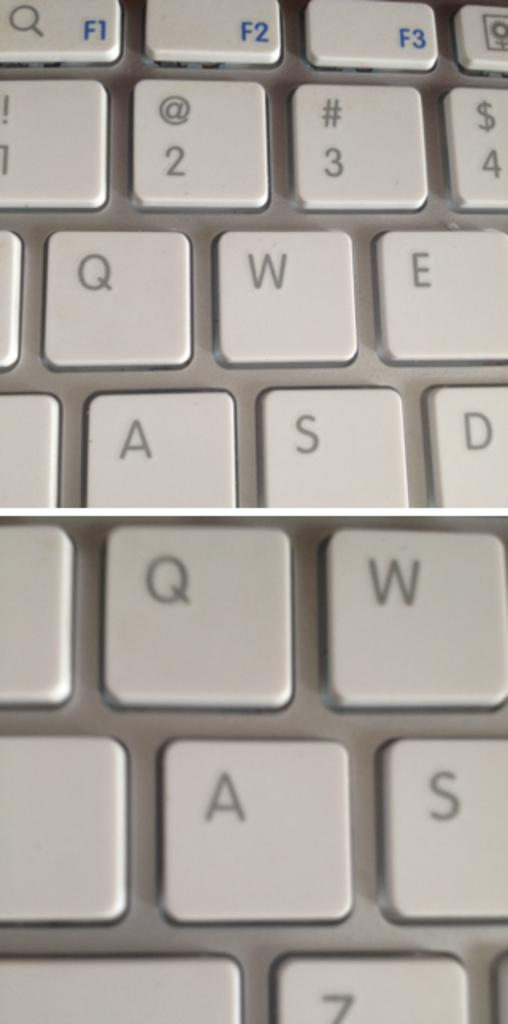<image>
Share a concise interpretation of the image provided. A zoomed in picture of a keyboard with letter A on the bottom 